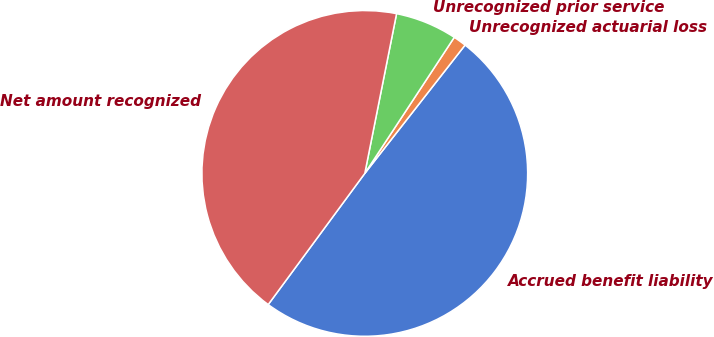<chart> <loc_0><loc_0><loc_500><loc_500><pie_chart><fcel>Accrued benefit liability<fcel>Unrecognized actuarial loss<fcel>Unrecognized prior service<fcel>Net amount recognized<nl><fcel>49.54%<fcel>1.3%<fcel>6.13%<fcel>43.02%<nl></chart> 